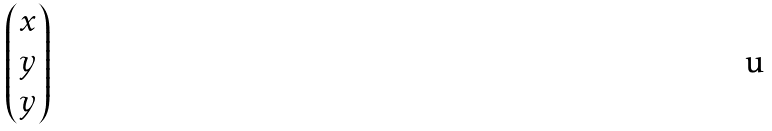Convert formula to latex. <formula><loc_0><loc_0><loc_500><loc_500>\begin{pmatrix} x \\ y \\ y \end{pmatrix}</formula> 